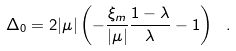<formula> <loc_0><loc_0><loc_500><loc_500>\Delta _ { 0 } = 2 | \mu | \left ( - \frac { \xi _ { m } } { | \mu | } \frac { 1 - \lambda } { \lambda } - 1 \right ) \ .</formula> 